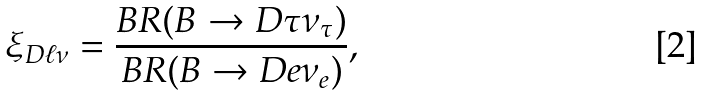<formula> <loc_0><loc_0><loc_500><loc_500>\xi _ { D \ell \nu } = \frac { B R ( B \to D \tau \nu _ { \tau } ) } { B R ( B \to D e \nu _ { e } ) } ,</formula> 